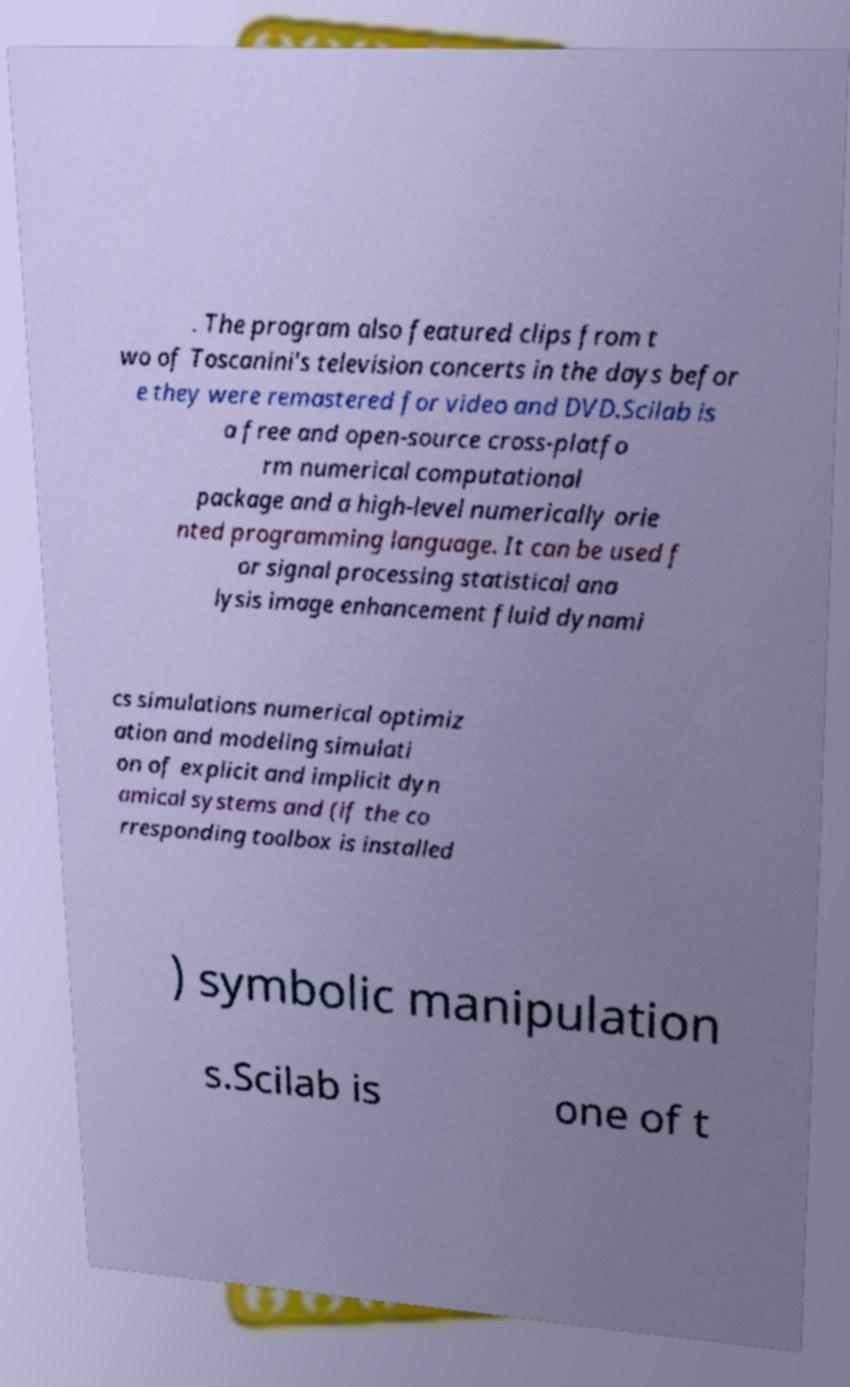Please read and relay the text visible in this image. What does it say? . The program also featured clips from t wo of Toscanini's television concerts in the days befor e they were remastered for video and DVD.Scilab is a free and open-source cross-platfo rm numerical computational package and a high-level numerically orie nted programming language. It can be used f or signal processing statistical ana lysis image enhancement fluid dynami cs simulations numerical optimiz ation and modeling simulati on of explicit and implicit dyn amical systems and (if the co rresponding toolbox is installed ) symbolic manipulation s.Scilab is one of t 